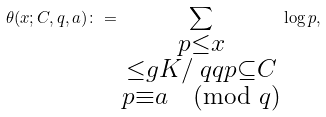Convert formula to latex. <formula><loc_0><loc_0><loc_500><loc_500>\theta ( x ; C , q , a ) \colon = \sum _ { \substack { p \leq x \\ \leq g { K / \ q q } { p } \subseteq C \\ p \equiv a \pmod { q } } } \log p ,</formula> 